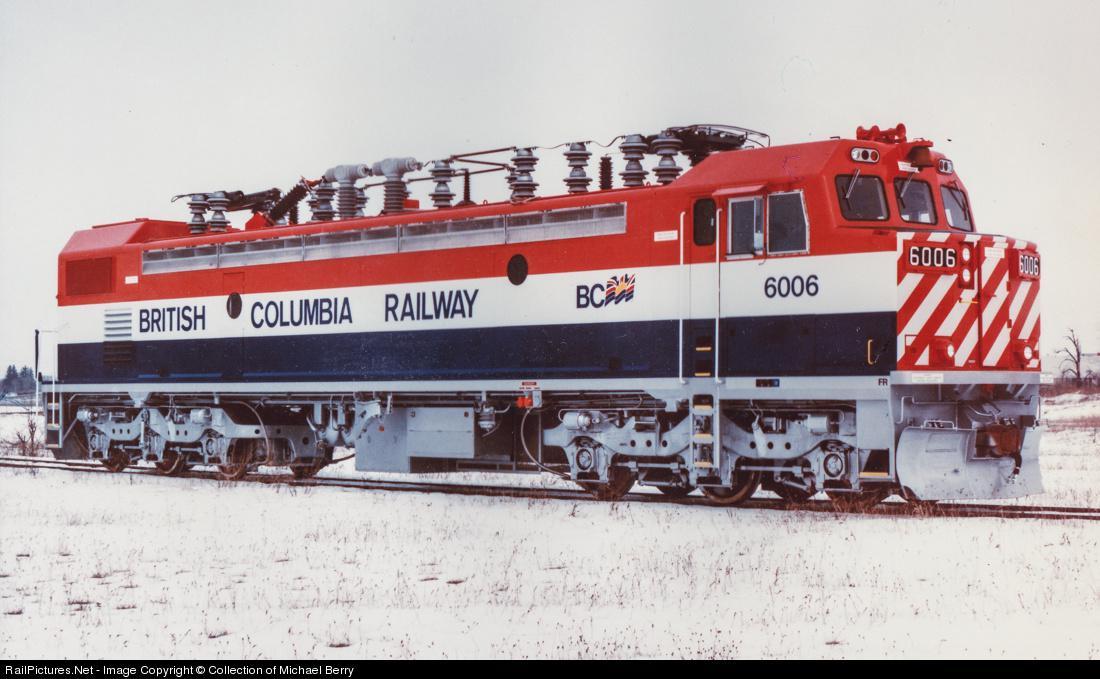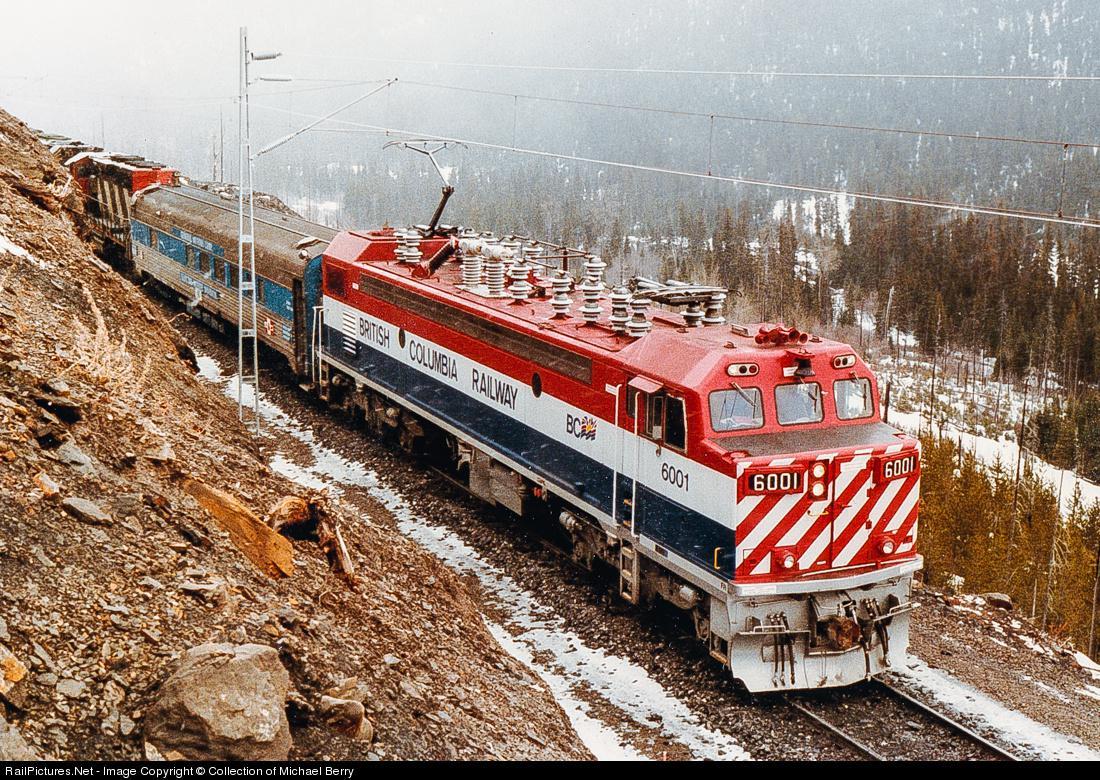The first image is the image on the left, the second image is the image on the right. Examine the images to the left and right. Is the description "Each image shows a red-topped train with white and blue stripes running horizontally along the side." accurate? Answer yes or no. Yes. The first image is the image on the left, the second image is the image on the right. For the images shown, is this caption "Both trains are red, white, and blue." true? Answer yes or no. Yes. 